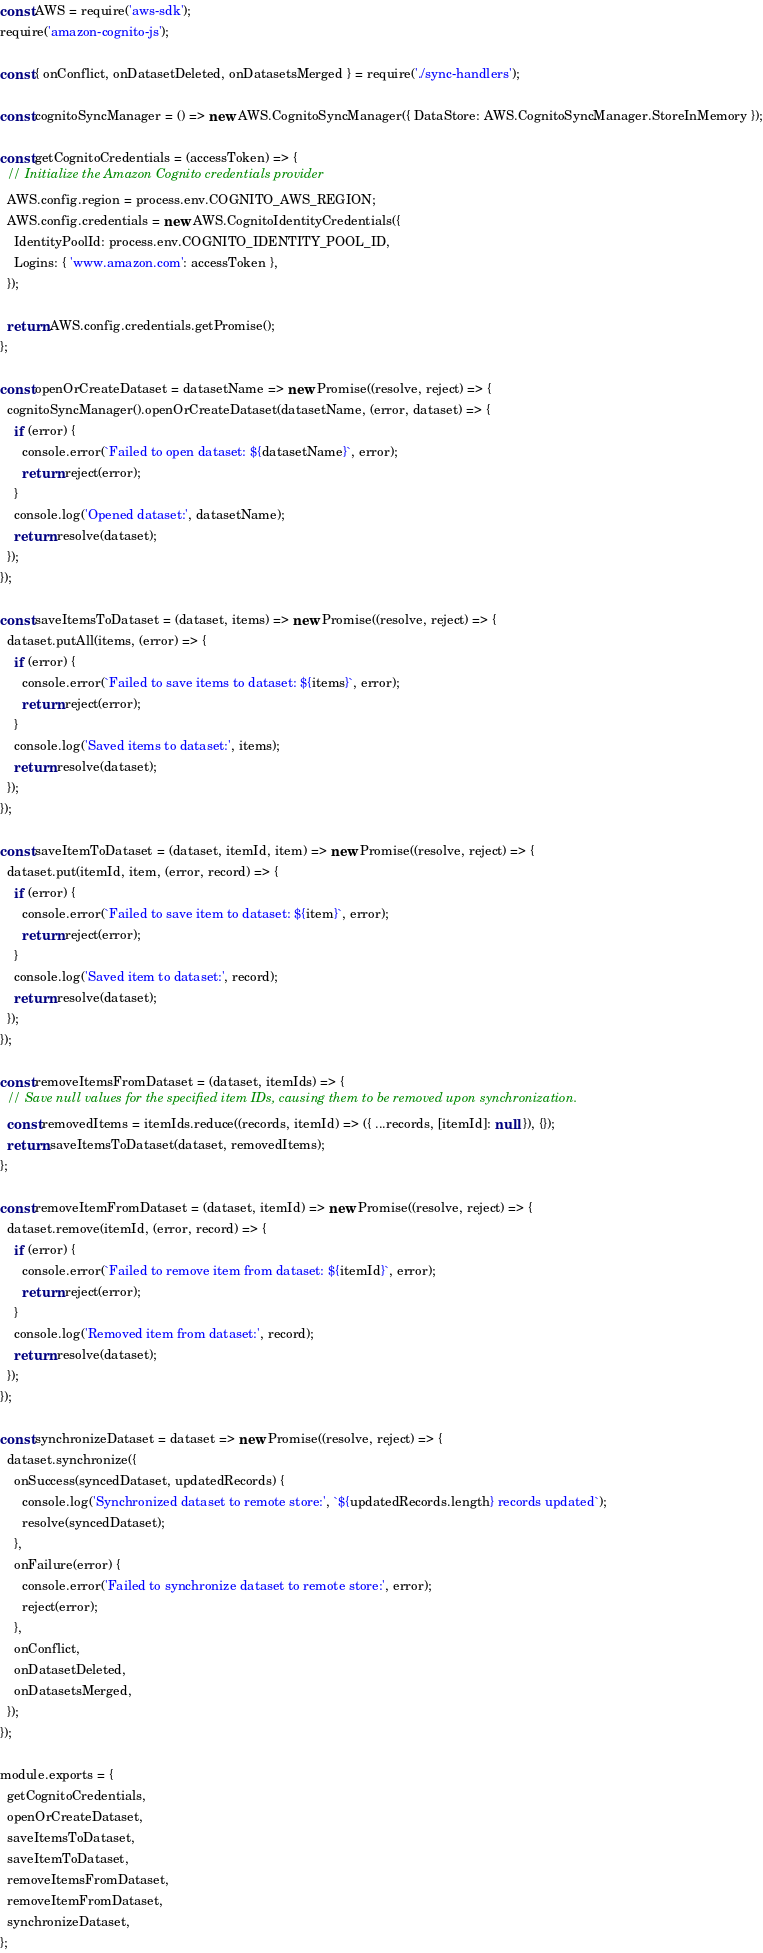<code> <loc_0><loc_0><loc_500><loc_500><_JavaScript_>const AWS = require('aws-sdk');
require('amazon-cognito-js');

const { onConflict, onDatasetDeleted, onDatasetsMerged } = require('./sync-handlers');

const cognitoSyncManager = () => new AWS.CognitoSyncManager({ DataStore: AWS.CognitoSyncManager.StoreInMemory });

const getCognitoCredentials = (accessToken) => {
  // Initialize the Amazon Cognito credentials provider
  AWS.config.region = process.env.COGNITO_AWS_REGION;
  AWS.config.credentials = new AWS.CognitoIdentityCredentials({
    IdentityPoolId: process.env.COGNITO_IDENTITY_POOL_ID,
    Logins: { 'www.amazon.com': accessToken },
  });

  return AWS.config.credentials.getPromise();
};

const openOrCreateDataset = datasetName => new Promise((resolve, reject) => {
  cognitoSyncManager().openOrCreateDataset(datasetName, (error, dataset) => {
    if (error) {
      console.error(`Failed to open dataset: ${datasetName}`, error);
      return reject(error);
    }
    console.log('Opened dataset:', datasetName);
    return resolve(dataset);
  });
});

const saveItemsToDataset = (dataset, items) => new Promise((resolve, reject) => {
  dataset.putAll(items, (error) => {
    if (error) {
      console.error(`Failed to save items to dataset: ${items}`, error);
      return reject(error);
    }
    console.log('Saved items to dataset:', items);
    return resolve(dataset);
  });
});

const saveItemToDataset = (dataset, itemId, item) => new Promise((resolve, reject) => {
  dataset.put(itemId, item, (error, record) => {
    if (error) {
      console.error(`Failed to save item to dataset: ${item}`, error);
      return reject(error);
    }
    console.log('Saved item to dataset:', record);
    return resolve(dataset);
  });
});

const removeItemsFromDataset = (dataset, itemIds) => {
  // Save null values for the specified item IDs, causing them to be removed upon synchronization.
  const removedItems = itemIds.reduce((records, itemId) => ({ ...records, [itemId]: null }), {});
  return saveItemsToDataset(dataset, removedItems);
};

const removeItemFromDataset = (dataset, itemId) => new Promise((resolve, reject) => {
  dataset.remove(itemId, (error, record) => {
    if (error) {
      console.error(`Failed to remove item from dataset: ${itemId}`, error);
      return reject(error);
    }
    console.log('Removed item from dataset:', record);
    return resolve(dataset);
  });
});

const synchronizeDataset = dataset => new Promise((resolve, reject) => {
  dataset.synchronize({
    onSuccess(syncedDataset, updatedRecords) {
      console.log('Synchronized dataset to remote store:', `${updatedRecords.length} records updated`);
      resolve(syncedDataset);
    },
    onFailure(error) {
      console.error('Failed to synchronize dataset to remote store:', error);
      reject(error);
    },
    onConflict,
    onDatasetDeleted,
    onDatasetsMerged,
  });
});

module.exports = {
  getCognitoCredentials,
  openOrCreateDataset,
  saveItemsToDataset,
  saveItemToDataset,
  removeItemsFromDataset,
  removeItemFromDataset,
  synchronizeDataset,
};
</code> 